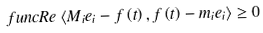<formula> <loc_0><loc_0><loc_500><loc_500>\ f u n c { R e } \left \langle M _ { i } e _ { i } - f \left ( t \right ) , f \left ( t \right ) - m _ { i } e _ { i } \right \rangle \geq 0 \text { \ }</formula> 